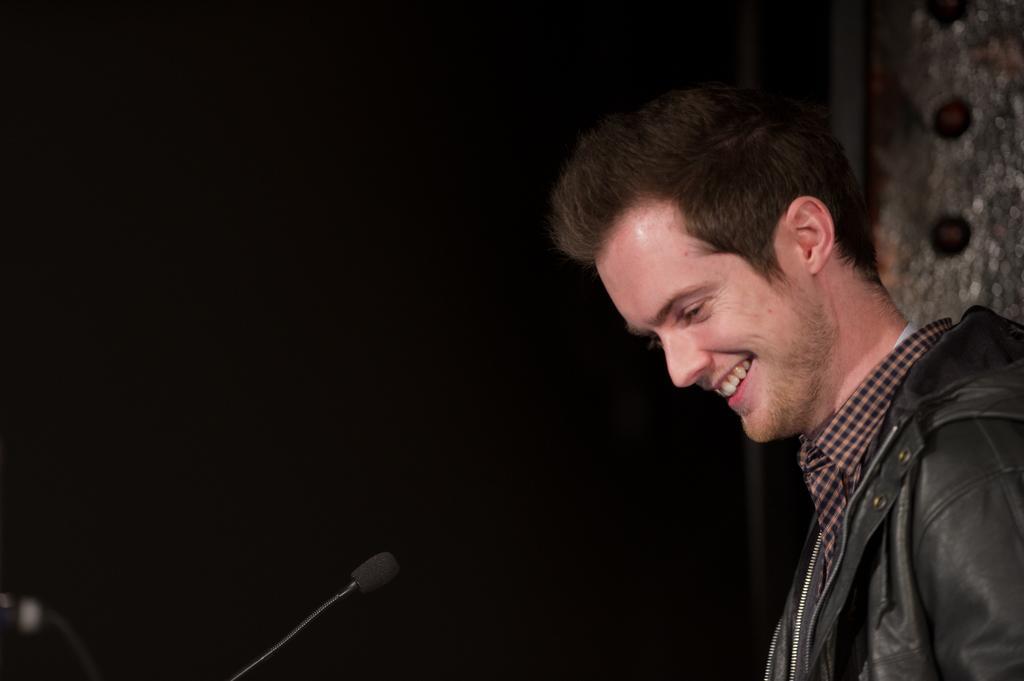Can you describe this image briefly? In this picture we can see a man in the black jacket is smiling and on the left side of the image there is a microphone and behind the man there is a dark background. 